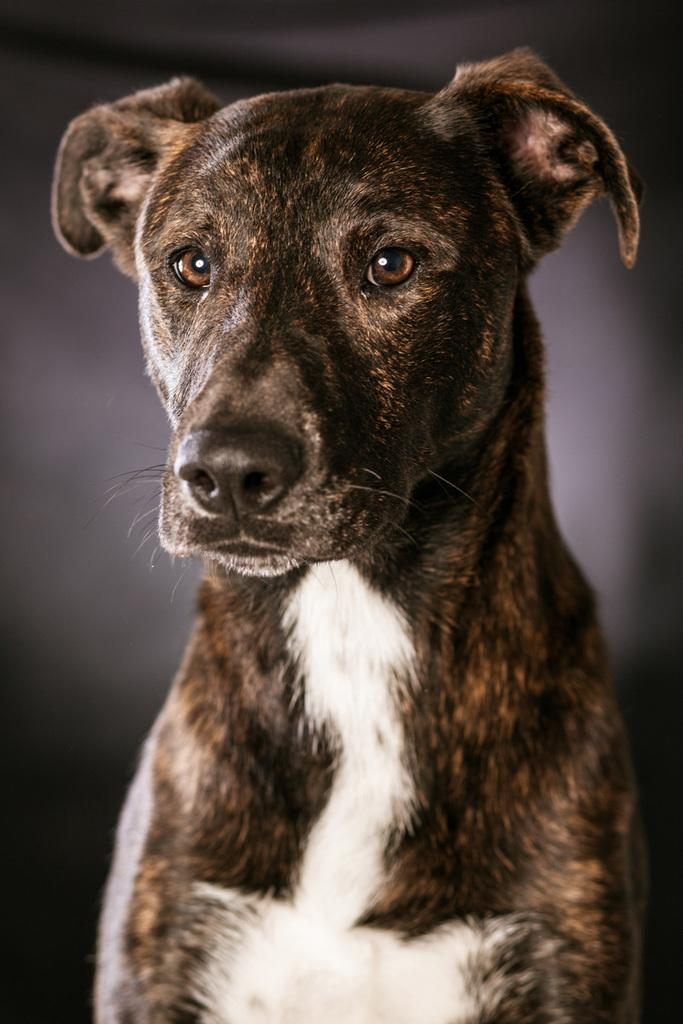What type of animal is in the image? There is a dog in the image. What color is the background of the image? The background of the image is black. What type of ear is visible on the dog in the image? There is no specific ear type mentioned in the facts, and the image does not provide enough detail to determine the dog's ear type. 